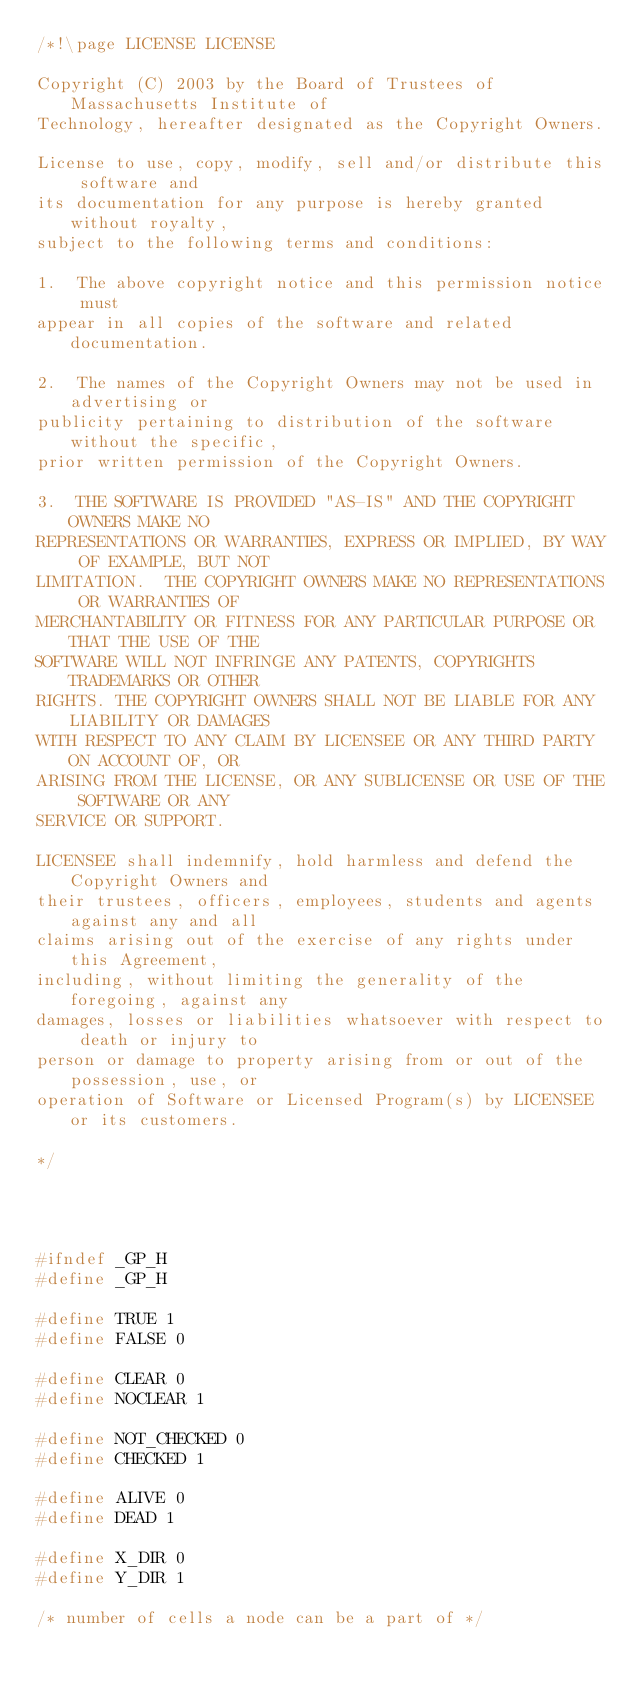<code> <loc_0><loc_0><loc_500><loc_500><_C_>/*!\page LICENSE LICENSE

Copyright (C) 2003 by the Board of Trustees of Massachusetts Institute of
Technology, hereafter designated as the Copyright Owners.

License to use, copy, modify, sell and/or distribute this software and
its documentation for any purpose is hereby granted without royalty,
subject to the following terms and conditions:

1.  The above copyright notice and this permission notice must
appear in all copies of the software and related documentation.

2.  The names of the Copyright Owners may not be used in advertising or
publicity pertaining to distribution of the software without the specific,
prior written permission of the Copyright Owners.

3.  THE SOFTWARE IS PROVIDED "AS-IS" AND THE COPYRIGHT OWNERS MAKE NO
REPRESENTATIONS OR WARRANTIES, EXPRESS OR IMPLIED, BY WAY OF EXAMPLE, BUT NOT
LIMITATION.  THE COPYRIGHT OWNERS MAKE NO REPRESENTATIONS OR WARRANTIES OF
MERCHANTABILITY OR FITNESS FOR ANY PARTICULAR PURPOSE OR THAT THE USE OF THE
SOFTWARE WILL NOT INFRINGE ANY PATENTS, COPYRIGHTS TRADEMARKS OR OTHER
RIGHTS. THE COPYRIGHT OWNERS SHALL NOT BE LIABLE FOR ANY LIABILITY OR DAMAGES
WITH RESPECT TO ANY CLAIM BY LICENSEE OR ANY THIRD PARTY ON ACCOUNT OF, OR
ARISING FROM THE LICENSE, OR ANY SUBLICENSE OR USE OF THE SOFTWARE OR ANY
SERVICE OR SUPPORT.

LICENSEE shall indemnify, hold harmless and defend the Copyright Owners and
their trustees, officers, employees, students and agents against any and all
claims arising out of the exercise of any rights under this Agreement,
including, without limiting the generality of the foregoing, against any
damages, losses or liabilities whatsoever with respect to death or injury to
person or damage to property arising from or out of the possession, use, or
operation of Software or Licensed Program(s) by LICENSEE or its customers.

*/




#ifndef _GP_H
#define _GP_H

#define TRUE 1
#define FALSE 0

#define CLEAR 0
#define NOCLEAR 1

#define NOT_CHECKED 0
#define CHECKED 1

#define ALIVE 0
#define DEAD 1

#define X_DIR 0
#define Y_DIR 1

/* number of cells a node can be a part of */</code> 